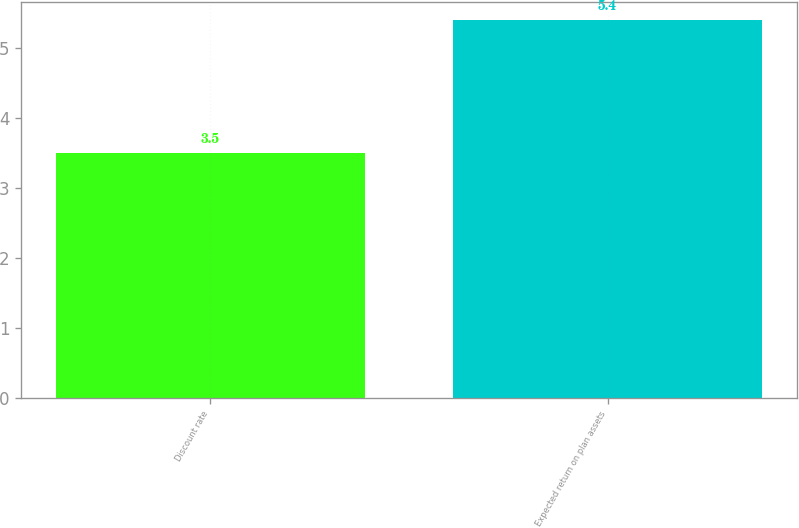Convert chart. <chart><loc_0><loc_0><loc_500><loc_500><bar_chart><fcel>Discount rate<fcel>Expected return on plan assets<nl><fcel>3.5<fcel>5.4<nl></chart> 